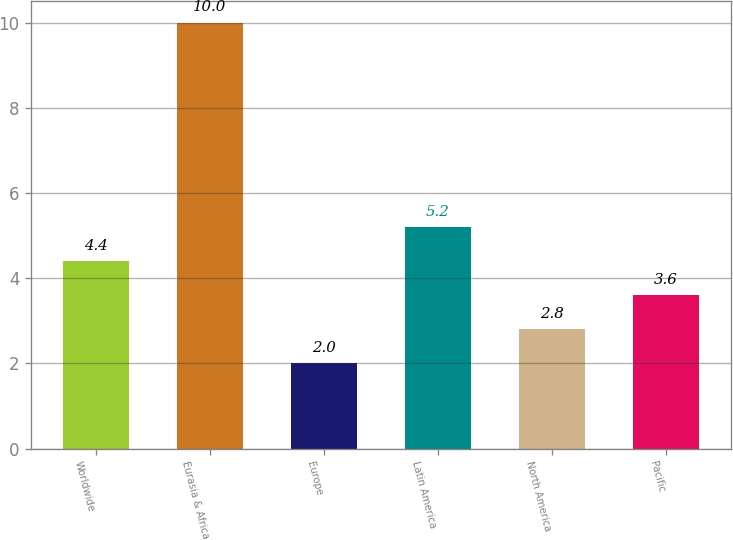Convert chart to OTSL. <chart><loc_0><loc_0><loc_500><loc_500><bar_chart><fcel>Worldwide<fcel>Eurasia & Africa<fcel>Europe<fcel>Latin America<fcel>North America<fcel>Pacific<nl><fcel>4.4<fcel>10<fcel>2<fcel>5.2<fcel>2.8<fcel>3.6<nl></chart> 